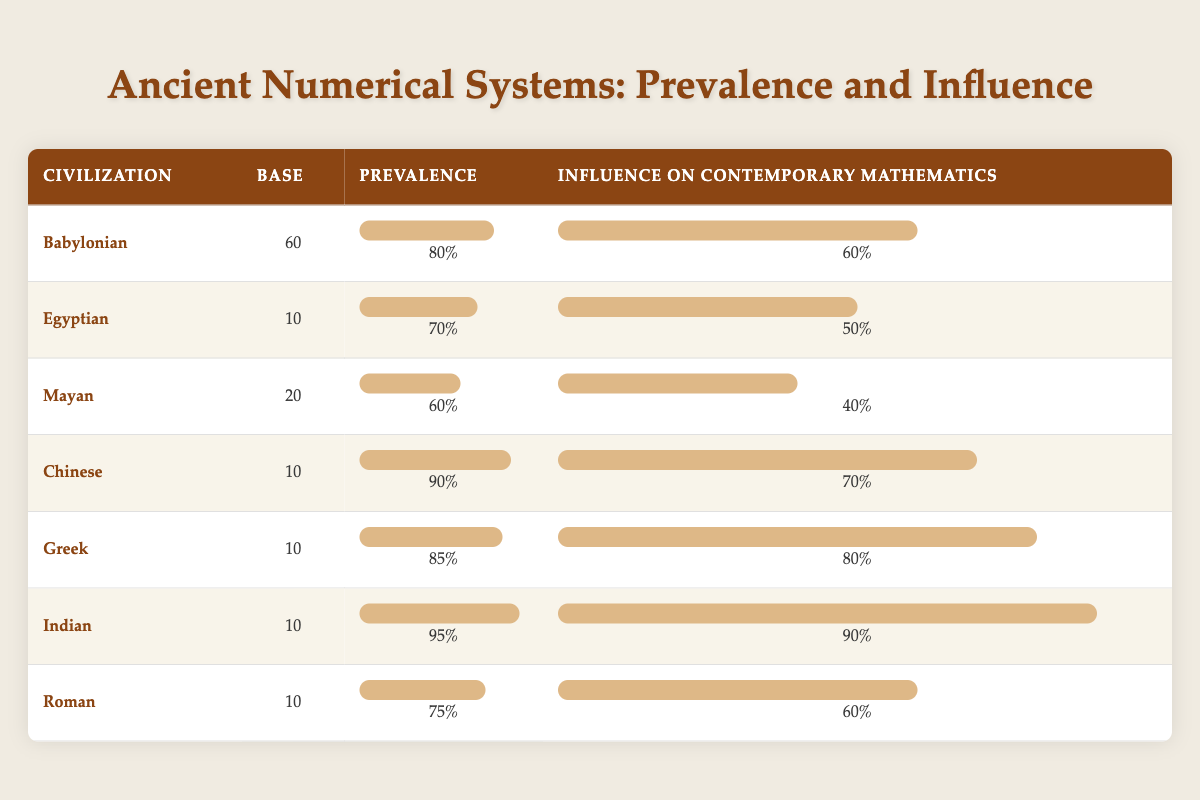What is the prevalence of the Babylonian numerical system? The table lists the Babylonian numerical system's prevalence as 0.8, or 80%.
Answer: 80% Which civilization has the highest influence on contemporary mathematics? By examining the influence values, the Indian civilization has the highest influence score of 0.9, or 90%.
Answer: Indian What is the average prevalence of the numerical systems listed? To calculate the average, we sum up the prevalence values: (0.8 + 0.7 + 0.6 + 0.9 + 0.85 + 0.95 + 0.75) = 5.6. There are 7 civilizations, so the average prevalence is 5.6 / 7 = approximately 0.8.
Answer: 0.8 Do all civilizations with a base of 10 have an influence score above 60%? The table shows that the Egyptian (0.5) and Roman (0.6) civilizations, both with a base of 10, have influence scores below 60%. So the statement is false.
Answer: No Is the influence on contemporary mathematics directly proportional to the prevalence for all civilizations? Among the civilizations, this is not true. For the Babylonian system, prevalence is 0.8 with influence 0.6. In comparison, the Indian system has a higher prevalence (0.95) and influence (0.9), indicating some correlation but not strict proportionality.
Answer: No 